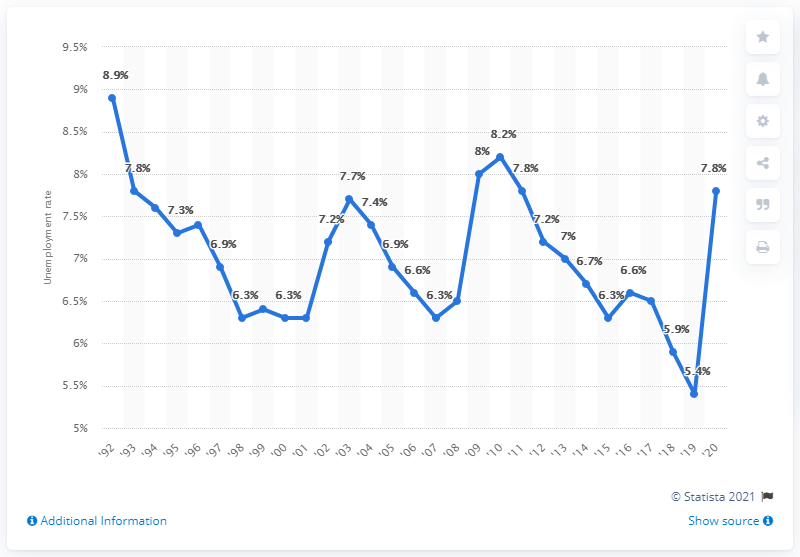Can you describe the trend in unemployment rates in Alaska from 2001 to 2020? The graph shows a fluctuating trend in Alaska's unemployment rates from 2001 to 2020. Initially, there's a significant decline from about 8.9% in 2001 to around 6.3% in 2006. This is followed by a periodic rise and fall, with notable peaks around 2010 and 2018, both close to 7.8%. The rate then drops sharply in 2020, ending at approximately 5.4%. 